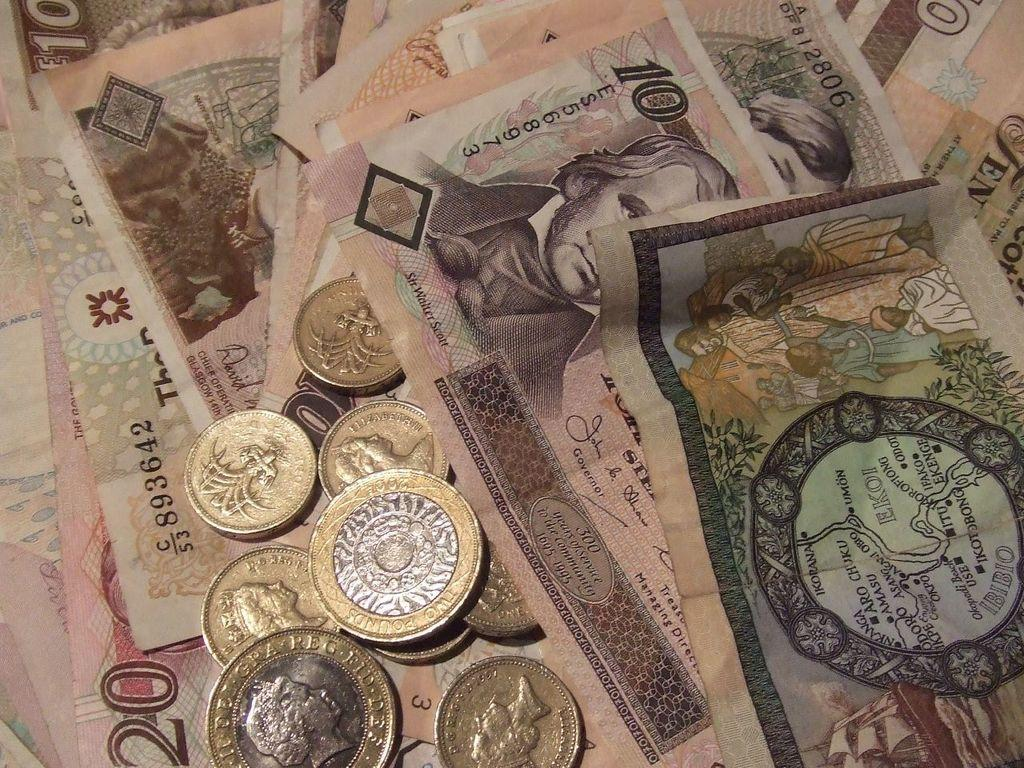<image>
Relay a brief, clear account of the picture shown. Foreign money bearing serial number 893642 is covered in coins. 